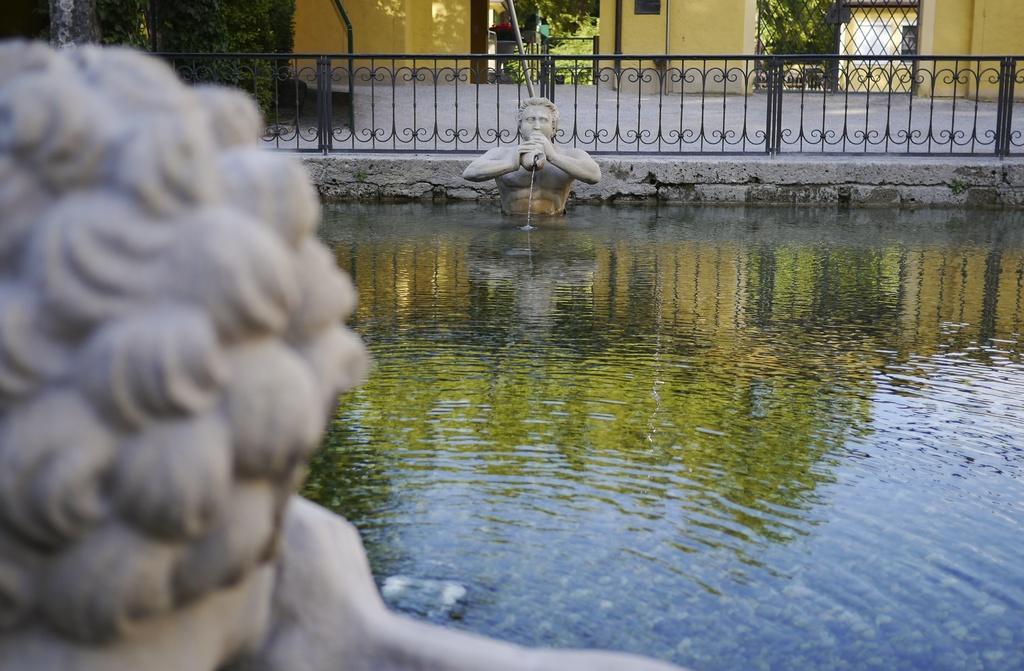In one or two sentences, can you explain what this image depicts? In this picture we can see two statues in water. There is some fencing from left to right. We can see few trees and some buildings in the background. 